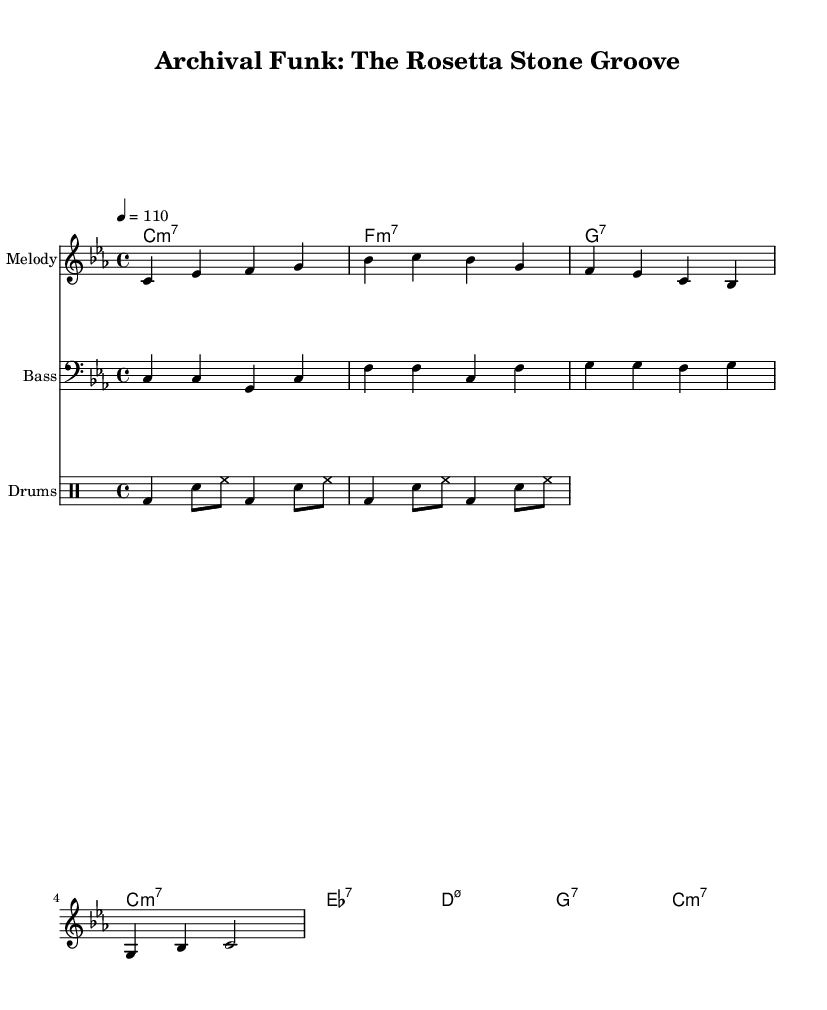What is the key signature of this music? The key signature is C minor, which contains three flats (B-flat, E-flat, and A-flat). It's determined from the global setting in the piece.
Answer: C minor What is the time signature of the music? The time signature is 4/4, indicating four beats in each measure, which is evident in the global settings of the score.
Answer: 4/4 What is the tempo marking given in the sheet music? The tempo marking is quarter note equals 110, indicating the speed at which the piece should be played, found in the global settings.
Answer: 110 What type of ensemble is this music arranged for? The arrangement is for a band format that includes melody, bass, and drums, as specified by the different staves in the score.
Answer: Band How many measures are there in the melody part? The melody consists of four measures, as counted through the provided melody notation. Each measure is separated by a vertical line.
Answer: Four Which historical artifact does the title refer to? The title refers to the Rosetta Stone, which is an ancient artifact that provided the key to understanding Egyptian hieroglyphs, as alluded to in the lyrics and title.
Answer: Rosetta Stone What chord follows the C minor 7 chord in the chord progression? The next chord in the progression is F minor 7, identified by the sequence provided in the chord names section.
Answer: F minor 7 